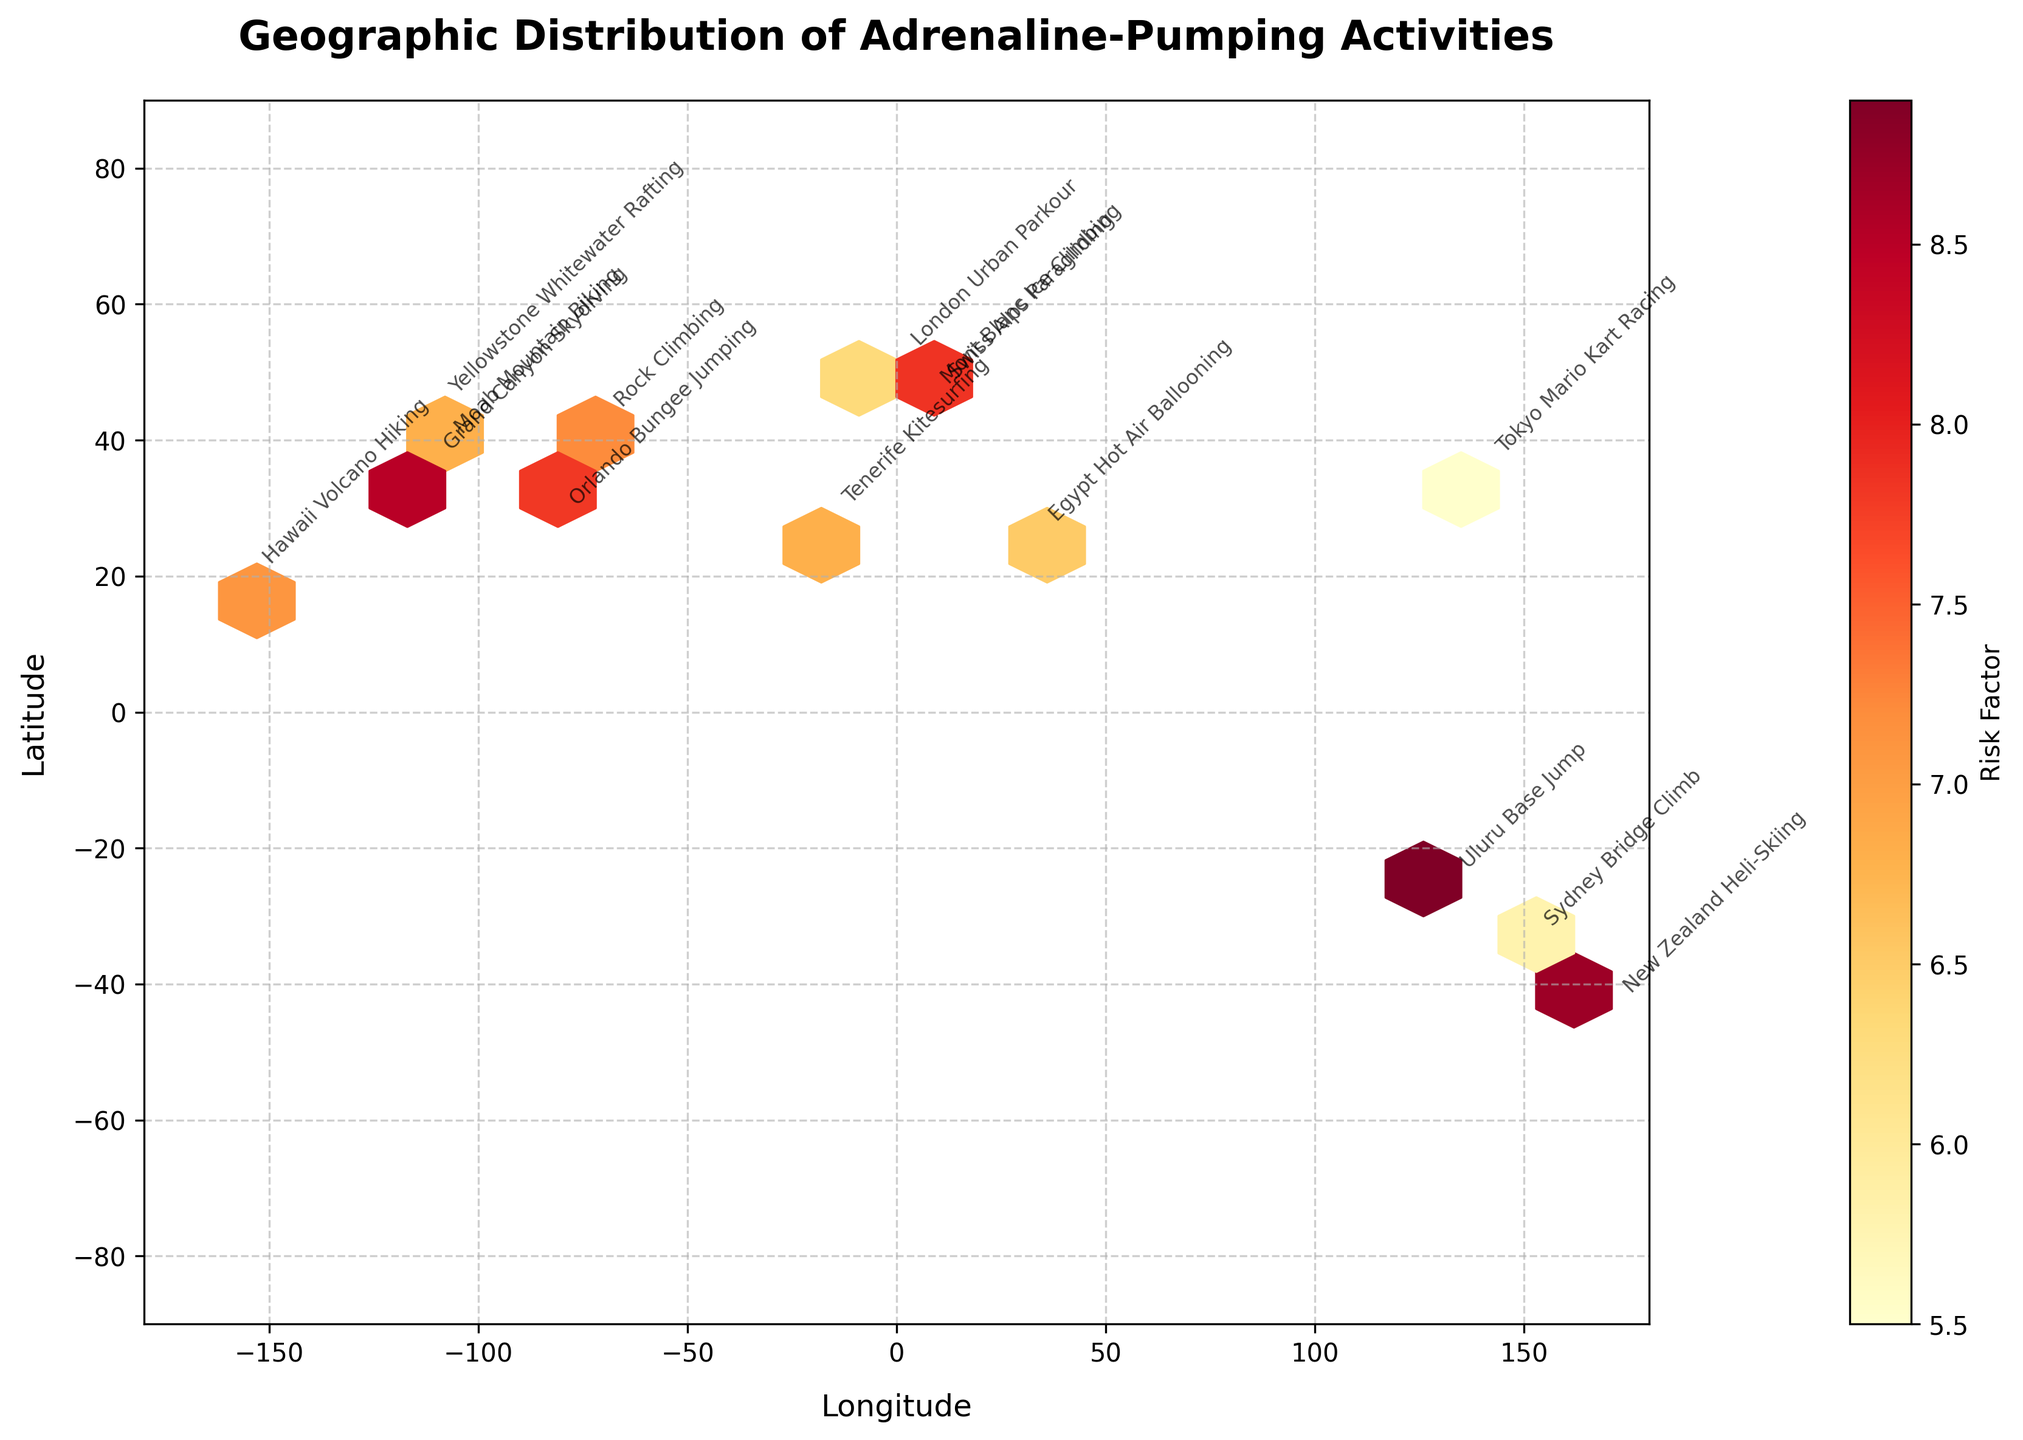What is the title of the figure? The title of the figure is displayed prominently at the top of the plot.
Answer: Geographic Distribution of Adrenaline-Pumping Activities What does the colorbar represent? The colorbar is labeled "Risk Factor," indicating it represents the risk factor associated with each activity location.
Answer: Risk Factor In which geographic region is the highest risk factor observed? By examining the color intensity on the hexbin plot, the highest risk factor appears to be around Uluru Base Jumping in Australia.
Answer: Uluru, Australia How would you describe the overall distribution of activities across the globe? The activities are spread out globally with concentrations visible in both the Northern and Southern Hemispheres. The activities are present on multiple continents including North America, Europe, Asia, Oceania, and Africa.
Answer: Globally spread Are there more high-risk activities in the Northern Hemisphere or the Southern Hemisphere? By counting the annotations and visually inspecting the hexbin plot, there are more high-risk activities located in the Northern Hemisphere.
Answer: Northern Hemisphere Which activity has the highest risk factor, and where is it located? The highest risk factor activity label can be read directly from the annotation near the highest color intensity, which is Uluru Base Jump in Australia.
Answer: Uluru Base Jump, Australia Which activity located in Europe has the highest risk factor? Identifying the activities annotated in Europe and comparing their color intensity on the hexbin plot, Mont Blanc Ice Climbing stands out with the highest risk factor.
Answer: Mont Blanc Ice Climbing Identify an activity in the figure associated with a mid-range risk factor and its location. By observing the mid-range colors in the colorbar and the corresponding annotations, Yellowstone Whitewater Rafting in the USA has a mid-range risk factor.
Answer: Yellowstone Whitewater Rafting, USA What is the risk factor of Orlando Bungee Jumping, and where is it located geographically? Looking at the annotation for "Orlando Bungee Jumping" and its corresponding color intensity, you can deduce the risk factor. It is located in Florida, USA.
Answer: 7.8, Florida, USA How many activities in the figure are located in Europe? By counting the annotations of activities located within Europe on the hexbin plot, there are two: London Urban Parkour and Mont Blanc Ice Climbing.
Answer: 2 